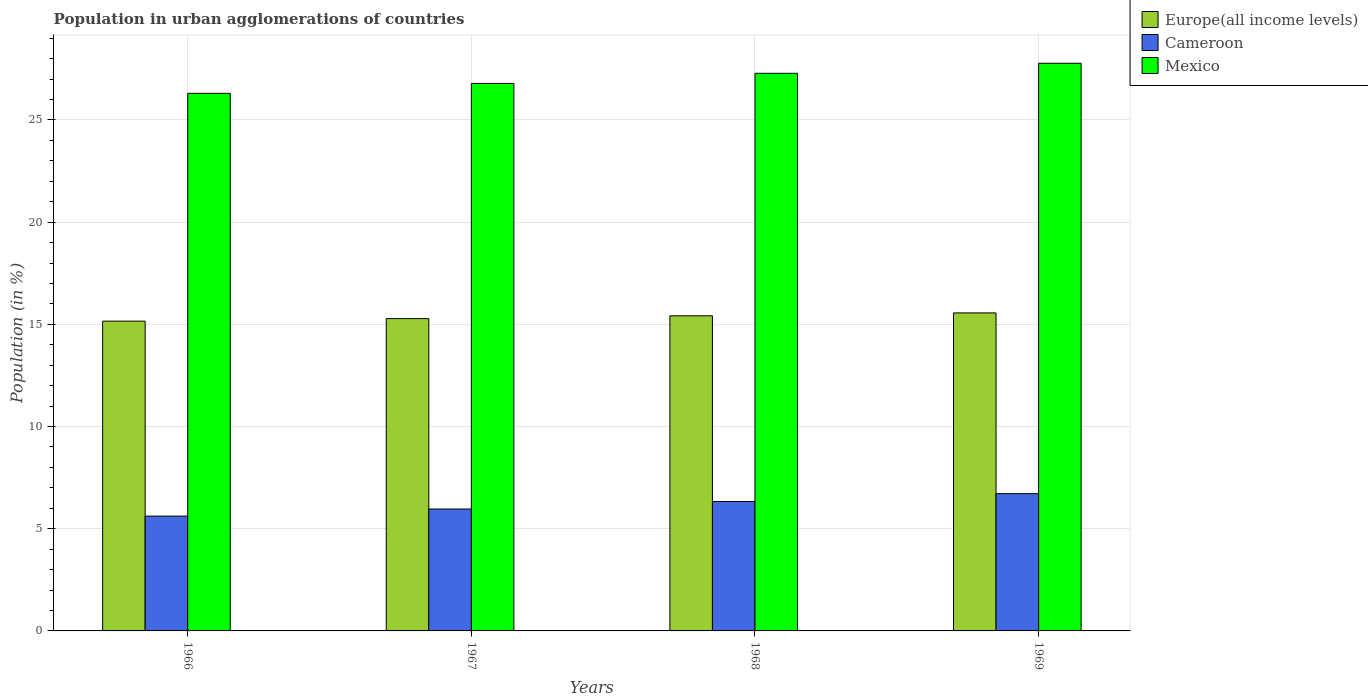How many different coloured bars are there?
Give a very brief answer. 3. How many groups of bars are there?
Provide a succinct answer. 4. Are the number of bars on each tick of the X-axis equal?
Provide a succinct answer. Yes. What is the label of the 3rd group of bars from the left?
Your response must be concise. 1968. What is the percentage of population in urban agglomerations in Mexico in 1969?
Your response must be concise. 27.77. Across all years, what is the maximum percentage of population in urban agglomerations in Mexico?
Provide a succinct answer. 27.77. Across all years, what is the minimum percentage of population in urban agglomerations in Europe(all income levels)?
Give a very brief answer. 15.16. In which year was the percentage of population in urban agglomerations in Cameroon maximum?
Your response must be concise. 1969. In which year was the percentage of population in urban agglomerations in Mexico minimum?
Offer a very short reply. 1966. What is the total percentage of population in urban agglomerations in Europe(all income levels) in the graph?
Keep it short and to the point. 61.42. What is the difference between the percentage of population in urban agglomerations in Mexico in 1966 and that in 1968?
Your response must be concise. -0.98. What is the difference between the percentage of population in urban agglomerations in Mexico in 1968 and the percentage of population in urban agglomerations in Cameroon in 1966?
Ensure brevity in your answer.  21.67. What is the average percentage of population in urban agglomerations in Cameroon per year?
Your answer should be very brief. 6.16. In the year 1967, what is the difference between the percentage of population in urban agglomerations in Europe(all income levels) and percentage of population in urban agglomerations in Cameroon?
Provide a short and direct response. 9.32. In how many years, is the percentage of population in urban agglomerations in Cameroon greater than 17 %?
Keep it short and to the point. 0. What is the ratio of the percentage of population in urban agglomerations in Europe(all income levels) in 1968 to that in 1969?
Offer a terse response. 0.99. Is the percentage of population in urban agglomerations in Cameroon in 1966 less than that in 1969?
Your answer should be very brief. Yes. What is the difference between the highest and the second highest percentage of population in urban agglomerations in Mexico?
Your answer should be very brief. 0.49. What is the difference between the highest and the lowest percentage of population in urban agglomerations in Europe(all income levels)?
Ensure brevity in your answer.  0.4. In how many years, is the percentage of population in urban agglomerations in Mexico greater than the average percentage of population in urban agglomerations in Mexico taken over all years?
Provide a succinct answer. 2. Is the sum of the percentage of population in urban agglomerations in Cameroon in 1968 and 1969 greater than the maximum percentage of population in urban agglomerations in Europe(all income levels) across all years?
Keep it short and to the point. No. What does the 3rd bar from the left in 1966 represents?
Offer a terse response. Mexico. What does the 3rd bar from the right in 1967 represents?
Keep it short and to the point. Europe(all income levels). Is it the case that in every year, the sum of the percentage of population in urban agglomerations in Europe(all income levels) and percentage of population in urban agglomerations in Mexico is greater than the percentage of population in urban agglomerations in Cameroon?
Your answer should be compact. Yes. How many bars are there?
Provide a short and direct response. 12. Are all the bars in the graph horizontal?
Provide a short and direct response. No. Are the values on the major ticks of Y-axis written in scientific E-notation?
Offer a terse response. No. Does the graph contain any zero values?
Make the answer very short. No. Does the graph contain grids?
Provide a short and direct response. Yes. Where does the legend appear in the graph?
Offer a very short reply. Top right. What is the title of the graph?
Offer a very short reply. Population in urban agglomerations of countries. Does "Kuwait" appear as one of the legend labels in the graph?
Give a very brief answer. No. What is the label or title of the Y-axis?
Your answer should be very brief. Population (in %). What is the Population (in %) in Europe(all income levels) in 1966?
Offer a terse response. 15.16. What is the Population (in %) of Cameroon in 1966?
Make the answer very short. 5.62. What is the Population (in %) in Mexico in 1966?
Offer a very short reply. 26.3. What is the Population (in %) in Europe(all income levels) in 1967?
Make the answer very short. 15.28. What is the Population (in %) of Cameroon in 1967?
Provide a short and direct response. 5.96. What is the Population (in %) of Mexico in 1967?
Ensure brevity in your answer.  26.79. What is the Population (in %) of Europe(all income levels) in 1968?
Ensure brevity in your answer.  15.42. What is the Population (in %) of Cameroon in 1968?
Your response must be concise. 6.33. What is the Population (in %) in Mexico in 1968?
Offer a terse response. 27.28. What is the Population (in %) of Europe(all income levels) in 1969?
Make the answer very short. 15.56. What is the Population (in %) of Cameroon in 1969?
Offer a very short reply. 6.72. What is the Population (in %) in Mexico in 1969?
Provide a succinct answer. 27.77. Across all years, what is the maximum Population (in %) of Europe(all income levels)?
Your answer should be very brief. 15.56. Across all years, what is the maximum Population (in %) of Cameroon?
Keep it short and to the point. 6.72. Across all years, what is the maximum Population (in %) in Mexico?
Provide a succinct answer. 27.77. Across all years, what is the minimum Population (in %) in Europe(all income levels)?
Ensure brevity in your answer.  15.16. Across all years, what is the minimum Population (in %) in Cameroon?
Provide a short and direct response. 5.62. Across all years, what is the minimum Population (in %) in Mexico?
Your answer should be very brief. 26.3. What is the total Population (in %) in Europe(all income levels) in the graph?
Keep it short and to the point. 61.42. What is the total Population (in %) in Cameroon in the graph?
Make the answer very short. 24.63. What is the total Population (in %) in Mexico in the graph?
Provide a short and direct response. 108.15. What is the difference between the Population (in %) in Europe(all income levels) in 1966 and that in 1967?
Provide a succinct answer. -0.12. What is the difference between the Population (in %) in Cameroon in 1966 and that in 1967?
Ensure brevity in your answer.  -0.35. What is the difference between the Population (in %) of Mexico in 1966 and that in 1967?
Keep it short and to the point. -0.48. What is the difference between the Population (in %) in Europe(all income levels) in 1966 and that in 1968?
Keep it short and to the point. -0.26. What is the difference between the Population (in %) of Cameroon in 1966 and that in 1968?
Your answer should be very brief. -0.71. What is the difference between the Population (in %) of Mexico in 1966 and that in 1968?
Offer a terse response. -0.98. What is the difference between the Population (in %) in Europe(all income levels) in 1966 and that in 1969?
Keep it short and to the point. -0.4. What is the difference between the Population (in %) of Cameroon in 1966 and that in 1969?
Provide a short and direct response. -1.1. What is the difference between the Population (in %) in Mexico in 1966 and that in 1969?
Give a very brief answer. -1.47. What is the difference between the Population (in %) in Europe(all income levels) in 1967 and that in 1968?
Provide a short and direct response. -0.14. What is the difference between the Population (in %) in Cameroon in 1967 and that in 1968?
Your answer should be compact. -0.37. What is the difference between the Population (in %) in Mexico in 1967 and that in 1968?
Offer a very short reply. -0.5. What is the difference between the Population (in %) of Europe(all income levels) in 1967 and that in 1969?
Make the answer very short. -0.28. What is the difference between the Population (in %) of Cameroon in 1967 and that in 1969?
Provide a succinct answer. -0.75. What is the difference between the Population (in %) of Mexico in 1967 and that in 1969?
Your response must be concise. -0.99. What is the difference between the Population (in %) of Europe(all income levels) in 1968 and that in 1969?
Offer a terse response. -0.14. What is the difference between the Population (in %) of Cameroon in 1968 and that in 1969?
Your answer should be compact. -0.38. What is the difference between the Population (in %) of Mexico in 1968 and that in 1969?
Your answer should be very brief. -0.49. What is the difference between the Population (in %) of Europe(all income levels) in 1966 and the Population (in %) of Cameroon in 1967?
Offer a terse response. 9.19. What is the difference between the Population (in %) of Europe(all income levels) in 1966 and the Population (in %) of Mexico in 1967?
Offer a very short reply. -11.63. What is the difference between the Population (in %) in Cameroon in 1966 and the Population (in %) in Mexico in 1967?
Your answer should be very brief. -21.17. What is the difference between the Population (in %) in Europe(all income levels) in 1966 and the Population (in %) in Cameroon in 1968?
Make the answer very short. 8.82. What is the difference between the Population (in %) of Europe(all income levels) in 1966 and the Population (in %) of Mexico in 1968?
Offer a very short reply. -12.13. What is the difference between the Population (in %) in Cameroon in 1966 and the Population (in %) in Mexico in 1968?
Make the answer very short. -21.67. What is the difference between the Population (in %) in Europe(all income levels) in 1966 and the Population (in %) in Cameroon in 1969?
Your response must be concise. 8.44. What is the difference between the Population (in %) of Europe(all income levels) in 1966 and the Population (in %) of Mexico in 1969?
Ensure brevity in your answer.  -12.62. What is the difference between the Population (in %) in Cameroon in 1966 and the Population (in %) in Mexico in 1969?
Provide a succinct answer. -22.16. What is the difference between the Population (in %) of Europe(all income levels) in 1967 and the Population (in %) of Cameroon in 1968?
Provide a succinct answer. 8.95. What is the difference between the Population (in %) in Europe(all income levels) in 1967 and the Population (in %) in Mexico in 1968?
Make the answer very short. -12. What is the difference between the Population (in %) in Cameroon in 1967 and the Population (in %) in Mexico in 1968?
Ensure brevity in your answer.  -21.32. What is the difference between the Population (in %) of Europe(all income levels) in 1967 and the Population (in %) of Cameroon in 1969?
Offer a terse response. 8.57. What is the difference between the Population (in %) in Europe(all income levels) in 1967 and the Population (in %) in Mexico in 1969?
Offer a very short reply. -12.49. What is the difference between the Population (in %) in Cameroon in 1967 and the Population (in %) in Mexico in 1969?
Your response must be concise. -21.81. What is the difference between the Population (in %) in Europe(all income levels) in 1968 and the Population (in %) in Cameroon in 1969?
Keep it short and to the point. 8.7. What is the difference between the Population (in %) in Europe(all income levels) in 1968 and the Population (in %) in Mexico in 1969?
Your answer should be very brief. -12.36. What is the difference between the Population (in %) in Cameroon in 1968 and the Population (in %) in Mexico in 1969?
Keep it short and to the point. -21.44. What is the average Population (in %) in Europe(all income levels) per year?
Give a very brief answer. 15.35. What is the average Population (in %) of Cameroon per year?
Provide a succinct answer. 6.16. What is the average Population (in %) of Mexico per year?
Keep it short and to the point. 27.04. In the year 1966, what is the difference between the Population (in %) in Europe(all income levels) and Population (in %) in Cameroon?
Give a very brief answer. 9.54. In the year 1966, what is the difference between the Population (in %) in Europe(all income levels) and Population (in %) in Mexico?
Keep it short and to the point. -11.15. In the year 1966, what is the difference between the Population (in %) in Cameroon and Population (in %) in Mexico?
Keep it short and to the point. -20.69. In the year 1967, what is the difference between the Population (in %) of Europe(all income levels) and Population (in %) of Cameroon?
Keep it short and to the point. 9.32. In the year 1967, what is the difference between the Population (in %) in Europe(all income levels) and Population (in %) in Mexico?
Offer a terse response. -11.51. In the year 1967, what is the difference between the Population (in %) in Cameroon and Population (in %) in Mexico?
Provide a succinct answer. -20.82. In the year 1968, what is the difference between the Population (in %) in Europe(all income levels) and Population (in %) in Cameroon?
Give a very brief answer. 9.09. In the year 1968, what is the difference between the Population (in %) in Europe(all income levels) and Population (in %) in Mexico?
Provide a succinct answer. -11.87. In the year 1968, what is the difference between the Population (in %) of Cameroon and Population (in %) of Mexico?
Your answer should be compact. -20.95. In the year 1969, what is the difference between the Population (in %) in Europe(all income levels) and Population (in %) in Cameroon?
Offer a terse response. 8.84. In the year 1969, what is the difference between the Population (in %) in Europe(all income levels) and Population (in %) in Mexico?
Provide a succinct answer. -12.22. In the year 1969, what is the difference between the Population (in %) in Cameroon and Population (in %) in Mexico?
Give a very brief answer. -21.06. What is the ratio of the Population (in %) of Cameroon in 1966 to that in 1967?
Your answer should be compact. 0.94. What is the ratio of the Population (in %) in Mexico in 1966 to that in 1967?
Keep it short and to the point. 0.98. What is the ratio of the Population (in %) in Europe(all income levels) in 1966 to that in 1968?
Give a very brief answer. 0.98. What is the ratio of the Population (in %) in Cameroon in 1966 to that in 1968?
Offer a terse response. 0.89. What is the ratio of the Population (in %) of Mexico in 1966 to that in 1968?
Your answer should be very brief. 0.96. What is the ratio of the Population (in %) of Europe(all income levels) in 1966 to that in 1969?
Your answer should be very brief. 0.97. What is the ratio of the Population (in %) in Cameroon in 1966 to that in 1969?
Provide a short and direct response. 0.84. What is the ratio of the Population (in %) in Mexico in 1966 to that in 1969?
Provide a succinct answer. 0.95. What is the ratio of the Population (in %) of Europe(all income levels) in 1967 to that in 1968?
Make the answer very short. 0.99. What is the ratio of the Population (in %) of Cameroon in 1967 to that in 1968?
Ensure brevity in your answer.  0.94. What is the ratio of the Population (in %) of Mexico in 1967 to that in 1968?
Keep it short and to the point. 0.98. What is the ratio of the Population (in %) of Europe(all income levels) in 1967 to that in 1969?
Give a very brief answer. 0.98. What is the ratio of the Population (in %) in Cameroon in 1967 to that in 1969?
Offer a very short reply. 0.89. What is the ratio of the Population (in %) in Mexico in 1967 to that in 1969?
Your answer should be very brief. 0.96. What is the ratio of the Population (in %) in Europe(all income levels) in 1968 to that in 1969?
Offer a terse response. 0.99. What is the ratio of the Population (in %) in Cameroon in 1968 to that in 1969?
Provide a succinct answer. 0.94. What is the ratio of the Population (in %) in Mexico in 1968 to that in 1969?
Offer a terse response. 0.98. What is the difference between the highest and the second highest Population (in %) of Europe(all income levels)?
Make the answer very short. 0.14. What is the difference between the highest and the second highest Population (in %) of Cameroon?
Keep it short and to the point. 0.38. What is the difference between the highest and the second highest Population (in %) in Mexico?
Offer a terse response. 0.49. What is the difference between the highest and the lowest Population (in %) of Europe(all income levels)?
Give a very brief answer. 0.4. What is the difference between the highest and the lowest Population (in %) of Cameroon?
Ensure brevity in your answer.  1.1. What is the difference between the highest and the lowest Population (in %) of Mexico?
Offer a very short reply. 1.47. 